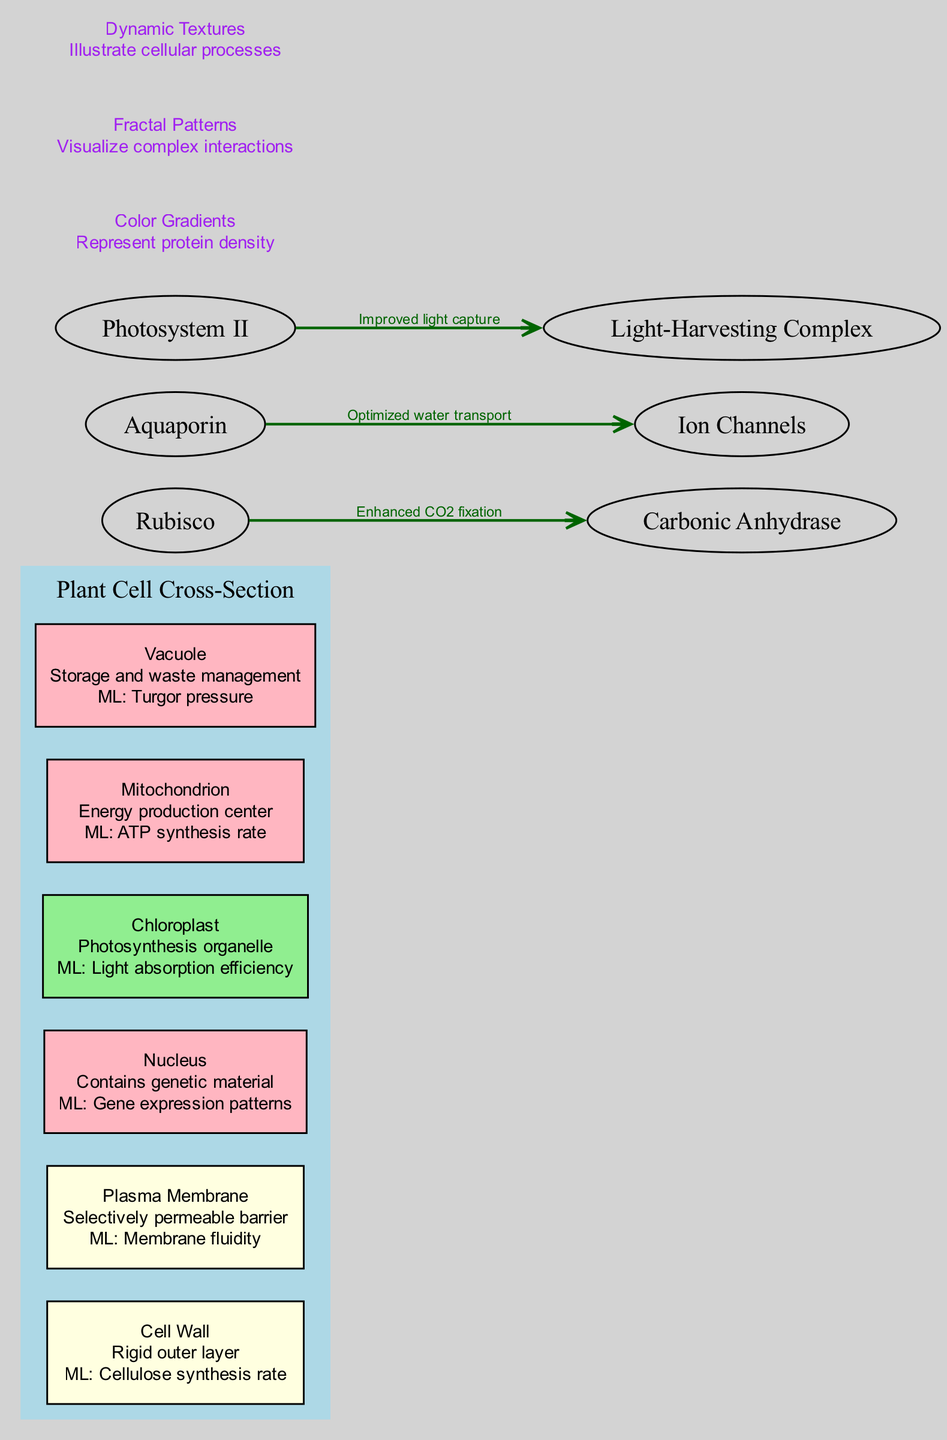What is the main structure represented in the diagram? The diagram indicates the main structure at the top, labeled as "Plant Cell Cross-Section." This is the primary focus of the diagram as it encapsulates all the components and their interactions, as well as artistic elements.
Answer: Plant Cell Cross-Section How many components are there in the plant cell cross-section? By reviewing the list of components in the diagram, six distinct items are identified: Cell Wall, Plasma Membrane, Nucleus, Chloroplast, Mitochondrion, and Vacuole. Therefore, the total count is six.
Answer: 6 What is the ML prediction associated with the Chloroplast? Focusing on the Chloroplast node, it is noted that it includes descriptive information about the organelle and its corresponding machine learning prediction, which is stated as "Light absorption efficiency."
Answer: Light absorption efficiency Which two proteins are predicted to enhance CO2 fixation? The diagram lists a specific interaction between "Rubisco" and "Carbonic Anhydrase," with a prediction of "Enhanced CO2 fixation." This connection is explicitly mentioned as part of the protein interactions section.
Answer: Rubisco and Carbonic Anhydrase What color represents the Cell Wall node in the diagram? When analyzing the nodes, the Cell Wall is filled with a color that is randomly selected. In this case, upon visual interpretation, it is found to be light yellow. The color choice is indicated in the diagram specification.
Answer: Light yellow Which cellular component is identified as the energy production center? The description accompanying the Mitochondrion makes it clear that it is recognized as the "Energy production center." This directly answers the designation of which component fulfills this role.
Answer: Mitochondrion What is the description associated with the Vacuole component? Upon examining the Vacuole node, it is described as "Storage and waste management," providing specific information regarding its function within the plant cell.
Answer: Storage and waste management How many protein interactions are predicted in the diagram? The interactions section of the diagram lists three distinct pairs of proteins along with their respective predictions. Counting these interactions gives a total of three.
Answer: 3 What artistic element is used to visualize complex interactions within the diagram? The artistic elements section reveals "Fractal Patterns" as a method to represent complex interactions. This is clearly stated as part of the diagram's artistic elements description.
Answer: Fractal Patterns 